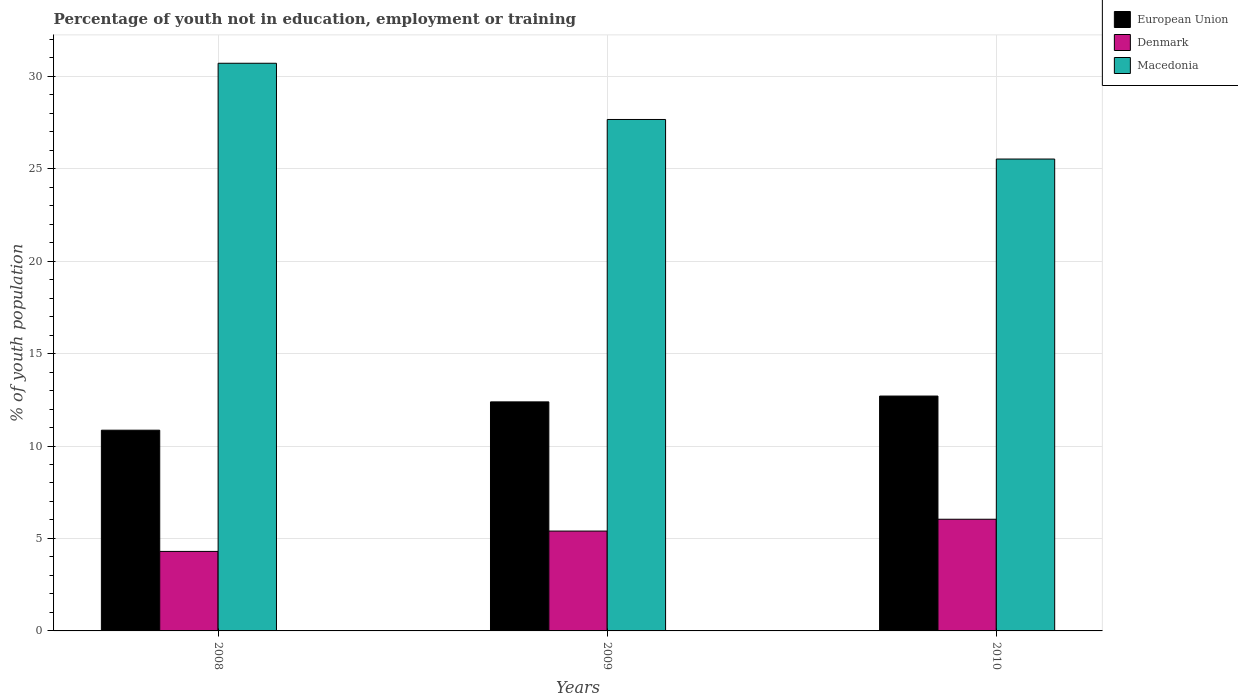How many different coloured bars are there?
Your answer should be very brief. 3. How many groups of bars are there?
Keep it short and to the point. 3. How many bars are there on the 3rd tick from the left?
Offer a very short reply. 3. How many bars are there on the 3rd tick from the right?
Provide a succinct answer. 3. In how many cases, is the number of bars for a given year not equal to the number of legend labels?
Keep it short and to the point. 0. What is the percentage of unemployed youth population in in Macedonia in 2008?
Provide a short and direct response. 30.7. Across all years, what is the maximum percentage of unemployed youth population in in Macedonia?
Keep it short and to the point. 30.7. Across all years, what is the minimum percentage of unemployed youth population in in Denmark?
Your answer should be very brief. 4.3. In which year was the percentage of unemployed youth population in in Denmark minimum?
Keep it short and to the point. 2008. What is the total percentage of unemployed youth population in in Macedonia in the graph?
Keep it short and to the point. 83.88. What is the difference between the percentage of unemployed youth population in in Macedonia in 2008 and that in 2009?
Your answer should be compact. 3.04. What is the difference between the percentage of unemployed youth population in in Macedonia in 2008 and the percentage of unemployed youth population in in European Union in 2010?
Provide a short and direct response. 18. What is the average percentage of unemployed youth population in in Denmark per year?
Make the answer very short. 5.25. In the year 2010, what is the difference between the percentage of unemployed youth population in in Denmark and percentage of unemployed youth population in in European Union?
Give a very brief answer. -6.66. In how many years, is the percentage of unemployed youth population in in Denmark greater than 8 %?
Make the answer very short. 0. What is the ratio of the percentage of unemployed youth population in in European Union in 2008 to that in 2010?
Provide a succinct answer. 0.85. Is the percentage of unemployed youth population in in Macedonia in 2008 less than that in 2010?
Provide a succinct answer. No. What is the difference between the highest and the second highest percentage of unemployed youth population in in Macedonia?
Offer a terse response. 3.04. What is the difference between the highest and the lowest percentage of unemployed youth population in in Macedonia?
Your answer should be compact. 5.18. In how many years, is the percentage of unemployed youth population in in Denmark greater than the average percentage of unemployed youth population in in Denmark taken over all years?
Give a very brief answer. 2. Is the sum of the percentage of unemployed youth population in in Macedonia in 2008 and 2009 greater than the maximum percentage of unemployed youth population in in Denmark across all years?
Your answer should be very brief. Yes. How many bars are there?
Keep it short and to the point. 9. Does the graph contain grids?
Ensure brevity in your answer.  Yes. Where does the legend appear in the graph?
Provide a short and direct response. Top right. How many legend labels are there?
Offer a terse response. 3. How are the legend labels stacked?
Provide a succinct answer. Vertical. What is the title of the graph?
Keep it short and to the point. Percentage of youth not in education, employment or training. What is the label or title of the Y-axis?
Keep it short and to the point. % of youth population. What is the % of youth population in European Union in 2008?
Keep it short and to the point. 10.86. What is the % of youth population in Denmark in 2008?
Provide a short and direct response. 4.3. What is the % of youth population of Macedonia in 2008?
Provide a short and direct response. 30.7. What is the % of youth population in European Union in 2009?
Offer a terse response. 12.39. What is the % of youth population in Denmark in 2009?
Give a very brief answer. 5.4. What is the % of youth population in Macedonia in 2009?
Provide a short and direct response. 27.66. What is the % of youth population of European Union in 2010?
Make the answer very short. 12.7. What is the % of youth population in Denmark in 2010?
Keep it short and to the point. 6.04. What is the % of youth population of Macedonia in 2010?
Ensure brevity in your answer.  25.52. Across all years, what is the maximum % of youth population of European Union?
Ensure brevity in your answer.  12.7. Across all years, what is the maximum % of youth population of Denmark?
Keep it short and to the point. 6.04. Across all years, what is the maximum % of youth population of Macedonia?
Keep it short and to the point. 30.7. Across all years, what is the minimum % of youth population of European Union?
Provide a succinct answer. 10.86. Across all years, what is the minimum % of youth population of Denmark?
Your answer should be very brief. 4.3. Across all years, what is the minimum % of youth population in Macedonia?
Offer a terse response. 25.52. What is the total % of youth population of European Union in the graph?
Offer a terse response. 35.94. What is the total % of youth population in Denmark in the graph?
Provide a short and direct response. 15.74. What is the total % of youth population of Macedonia in the graph?
Keep it short and to the point. 83.88. What is the difference between the % of youth population of European Union in 2008 and that in 2009?
Provide a short and direct response. -1.53. What is the difference between the % of youth population of Denmark in 2008 and that in 2009?
Offer a terse response. -1.1. What is the difference between the % of youth population of Macedonia in 2008 and that in 2009?
Your answer should be very brief. 3.04. What is the difference between the % of youth population of European Union in 2008 and that in 2010?
Make the answer very short. -1.85. What is the difference between the % of youth population of Denmark in 2008 and that in 2010?
Keep it short and to the point. -1.74. What is the difference between the % of youth population of Macedonia in 2008 and that in 2010?
Your response must be concise. 5.18. What is the difference between the % of youth population of European Union in 2009 and that in 2010?
Your answer should be compact. -0.31. What is the difference between the % of youth population in Denmark in 2009 and that in 2010?
Provide a succinct answer. -0.64. What is the difference between the % of youth population of Macedonia in 2009 and that in 2010?
Your response must be concise. 2.14. What is the difference between the % of youth population in European Union in 2008 and the % of youth population in Denmark in 2009?
Give a very brief answer. 5.46. What is the difference between the % of youth population of European Union in 2008 and the % of youth population of Macedonia in 2009?
Offer a very short reply. -16.8. What is the difference between the % of youth population of Denmark in 2008 and the % of youth population of Macedonia in 2009?
Make the answer very short. -23.36. What is the difference between the % of youth population in European Union in 2008 and the % of youth population in Denmark in 2010?
Your response must be concise. 4.82. What is the difference between the % of youth population in European Union in 2008 and the % of youth population in Macedonia in 2010?
Keep it short and to the point. -14.66. What is the difference between the % of youth population of Denmark in 2008 and the % of youth population of Macedonia in 2010?
Offer a very short reply. -21.22. What is the difference between the % of youth population in European Union in 2009 and the % of youth population in Denmark in 2010?
Offer a terse response. 6.35. What is the difference between the % of youth population of European Union in 2009 and the % of youth population of Macedonia in 2010?
Your answer should be very brief. -13.13. What is the difference between the % of youth population of Denmark in 2009 and the % of youth population of Macedonia in 2010?
Keep it short and to the point. -20.12. What is the average % of youth population of European Union per year?
Provide a short and direct response. 11.98. What is the average % of youth population of Denmark per year?
Ensure brevity in your answer.  5.25. What is the average % of youth population in Macedonia per year?
Your answer should be very brief. 27.96. In the year 2008, what is the difference between the % of youth population of European Union and % of youth population of Denmark?
Keep it short and to the point. 6.56. In the year 2008, what is the difference between the % of youth population of European Union and % of youth population of Macedonia?
Offer a terse response. -19.84. In the year 2008, what is the difference between the % of youth population in Denmark and % of youth population in Macedonia?
Make the answer very short. -26.4. In the year 2009, what is the difference between the % of youth population in European Union and % of youth population in Denmark?
Make the answer very short. 6.99. In the year 2009, what is the difference between the % of youth population in European Union and % of youth population in Macedonia?
Make the answer very short. -15.27. In the year 2009, what is the difference between the % of youth population in Denmark and % of youth population in Macedonia?
Your answer should be compact. -22.26. In the year 2010, what is the difference between the % of youth population in European Union and % of youth population in Denmark?
Your answer should be compact. 6.66. In the year 2010, what is the difference between the % of youth population of European Union and % of youth population of Macedonia?
Ensure brevity in your answer.  -12.82. In the year 2010, what is the difference between the % of youth population of Denmark and % of youth population of Macedonia?
Your answer should be compact. -19.48. What is the ratio of the % of youth population of European Union in 2008 to that in 2009?
Your answer should be compact. 0.88. What is the ratio of the % of youth population of Denmark in 2008 to that in 2009?
Keep it short and to the point. 0.8. What is the ratio of the % of youth population of Macedonia in 2008 to that in 2009?
Your answer should be very brief. 1.11. What is the ratio of the % of youth population in European Union in 2008 to that in 2010?
Keep it short and to the point. 0.85. What is the ratio of the % of youth population of Denmark in 2008 to that in 2010?
Keep it short and to the point. 0.71. What is the ratio of the % of youth population in Macedonia in 2008 to that in 2010?
Give a very brief answer. 1.2. What is the ratio of the % of youth population in European Union in 2009 to that in 2010?
Your answer should be very brief. 0.98. What is the ratio of the % of youth population in Denmark in 2009 to that in 2010?
Your answer should be compact. 0.89. What is the ratio of the % of youth population of Macedonia in 2009 to that in 2010?
Ensure brevity in your answer.  1.08. What is the difference between the highest and the second highest % of youth population in European Union?
Keep it short and to the point. 0.31. What is the difference between the highest and the second highest % of youth population in Denmark?
Offer a terse response. 0.64. What is the difference between the highest and the second highest % of youth population of Macedonia?
Keep it short and to the point. 3.04. What is the difference between the highest and the lowest % of youth population of European Union?
Your answer should be compact. 1.85. What is the difference between the highest and the lowest % of youth population in Denmark?
Ensure brevity in your answer.  1.74. What is the difference between the highest and the lowest % of youth population in Macedonia?
Ensure brevity in your answer.  5.18. 